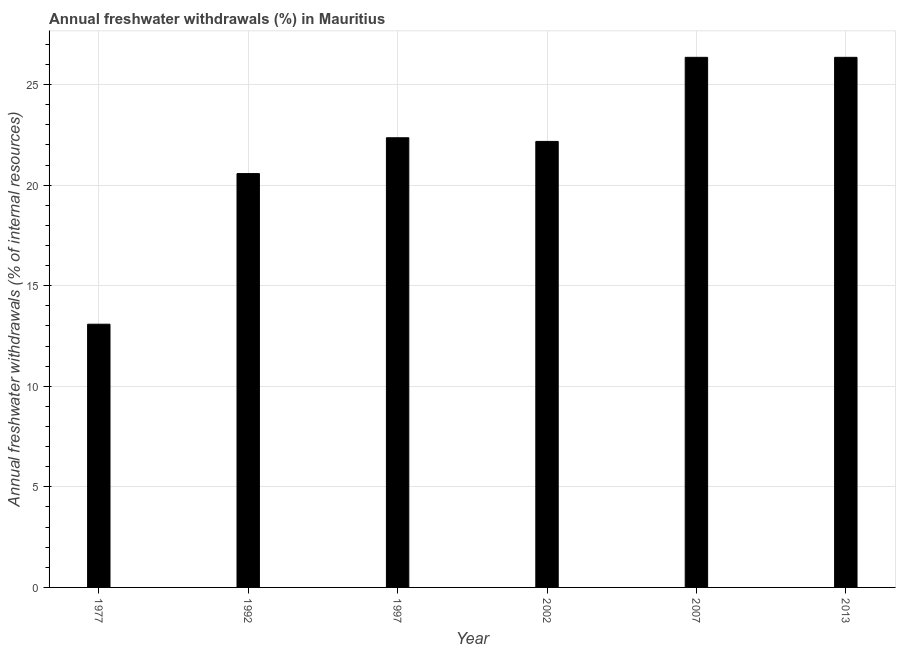Does the graph contain any zero values?
Offer a terse response. No. What is the title of the graph?
Make the answer very short. Annual freshwater withdrawals (%) in Mauritius. What is the label or title of the Y-axis?
Offer a terse response. Annual freshwater withdrawals (% of internal resources). What is the annual freshwater withdrawals in 2013?
Give a very brief answer. 26.35. Across all years, what is the maximum annual freshwater withdrawals?
Your answer should be very brief. 26.35. Across all years, what is the minimum annual freshwater withdrawals?
Offer a very short reply. 13.09. In which year was the annual freshwater withdrawals maximum?
Offer a very short reply. 2007. In which year was the annual freshwater withdrawals minimum?
Your answer should be compact. 1977. What is the sum of the annual freshwater withdrawals?
Offer a terse response. 130.9. What is the difference between the annual freshwater withdrawals in 1992 and 2013?
Keep it short and to the point. -5.78. What is the average annual freshwater withdrawals per year?
Offer a very short reply. 21.82. What is the median annual freshwater withdrawals?
Give a very brief answer. 22.26. Do a majority of the years between 1992 and 2013 (inclusive) have annual freshwater withdrawals greater than 15 %?
Give a very brief answer. Yes. What is the difference between the highest and the second highest annual freshwater withdrawals?
Keep it short and to the point. 0. What is the difference between the highest and the lowest annual freshwater withdrawals?
Your answer should be compact. 13.27. In how many years, is the annual freshwater withdrawals greater than the average annual freshwater withdrawals taken over all years?
Your answer should be compact. 4. How many bars are there?
Offer a very short reply. 6. Are all the bars in the graph horizontal?
Give a very brief answer. No. How many years are there in the graph?
Make the answer very short. 6. What is the difference between two consecutive major ticks on the Y-axis?
Offer a very short reply. 5. What is the Annual freshwater withdrawals (% of internal resources) of 1977?
Provide a succinct answer. 13.09. What is the Annual freshwater withdrawals (% of internal resources) in 1992?
Ensure brevity in your answer.  20.57. What is the Annual freshwater withdrawals (% of internal resources) in 1997?
Your answer should be very brief. 22.36. What is the Annual freshwater withdrawals (% of internal resources) of 2002?
Your response must be concise. 22.17. What is the Annual freshwater withdrawals (% of internal resources) of 2007?
Ensure brevity in your answer.  26.35. What is the Annual freshwater withdrawals (% of internal resources) of 2013?
Offer a terse response. 26.35. What is the difference between the Annual freshwater withdrawals (% of internal resources) in 1977 and 1992?
Your response must be concise. -7.49. What is the difference between the Annual freshwater withdrawals (% of internal resources) in 1977 and 1997?
Give a very brief answer. -9.27. What is the difference between the Annual freshwater withdrawals (% of internal resources) in 1977 and 2002?
Provide a succinct answer. -9.09. What is the difference between the Annual freshwater withdrawals (% of internal resources) in 1977 and 2007?
Your answer should be compact. -13.27. What is the difference between the Annual freshwater withdrawals (% of internal resources) in 1977 and 2013?
Offer a terse response. -13.27. What is the difference between the Annual freshwater withdrawals (% of internal resources) in 1992 and 1997?
Ensure brevity in your answer.  -1.78. What is the difference between the Annual freshwater withdrawals (% of internal resources) in 1992 and 2002?
Provide a short and direct response. -1.6. What is the difference between the Annual freshwater withdrawals (% of internal resources) in 1992 and 2007?
Give a very brief answer. -5.78. What is the difference between the Annual freshwater withdrawals (% of internal resources) in 1992 and 2013?
Give a very brief answer. -5.78. What is the difference between the Annual freshwater withdrawals (% of internal resources) in 1997 and 2002?
Ensure brevity in your answer.  0.18. What is the difference between the Annual freshwater withdrawals (% of internal resources) in 1997 and 2007?
Offer a very short reply. -4. What is the difference between the Annual freshwater withdrawals (% of internal resources) in 1997 and 2013?
Offer a terse response. -4. What is the difference between the Annual freshwater withdrawals (% of internal resources) in 2002 and 2007?
Provide a short and direct response. -4.18. What is the difference between the Annual freshwater withdrawals (% of internal resources) in 2002 and 2013?
Offer a terse response. -4.18. What is the difference between the Annual freshwater withdrawals (% of internal resources) in 2007 and 2013?
Your answer should be compact. 0. What is the ratio of the Annual freshwater withdrawals (% of internal resources) in 1977 to that in 1992?
Keep it short and to the point. 0.64. What is the ratio of the Annual freshwater withdrawals (% of internal resources) in 1977 to that in 1997?
Keep it short and to the point. 0.58. What is the ratio of the Annual freshwater withdrawals (% of internal resources) in 1977 to that in 2002?
Provide a succinct answer. 0.59. What is the ratio of the Annual freshwater withdrawals (% of internal resources) in 1977 to that in 2007?
Provide a short and direct response. 0.5. What is the ratio of the Annual freshwater withdrawals (% of internal resources) in 1977 to that in 2013?
Ensure brevity in your answer.  0.5. What is the ratio of the Annual freshwater withdrawals (% of internal resources) in 1992 to that in 1997?
Your answer should be very brief. 0.92. What is the ratio of the Annual freshwater withdrawals (% of internal resources) in 1992 to that in 2002?
Keep it short and to the point. 0.93. What is the ratio of the Annual freshwater withdrawals (% of internal resources) in 1992 to that in 2007?
Offer a very short reply. 0.78. What is the ratio of the Annual freshwater withdrawals (% of internal resources) in 1992 to that in 2013?
Provide a succinct answer. 0.78. What is the ratio of the Annual freshwater withdrawals (% of internal resources) in 1997 to that in 2002?
Give a very brief answer. 1.01. What is the ratio of the Annual freshwater withdrawals (% of internal resources) in 1997 to that in 2007?
Your response must be concise. 0.85. What is the ratio of the Annual freshwater withdrawals (% of internal resources) in 1997 to that in 2013?
Your answer should be very brief. 0.85. What is the ratio of the Annual freshwater withdrawals (% of internal resources) in 2002 to that in 2007?
Give a very brief answer. 0.84. What is the ratio of the Annual freshwater withdrawals (% of internal resources) in 2002 to that in 2013?
Make the answer very short. 0.84. What is the ratio of the Annual freshwater withdrawals (% of internal resources) in 2007 to that in 2013?
Give a very brief answer. 1. 